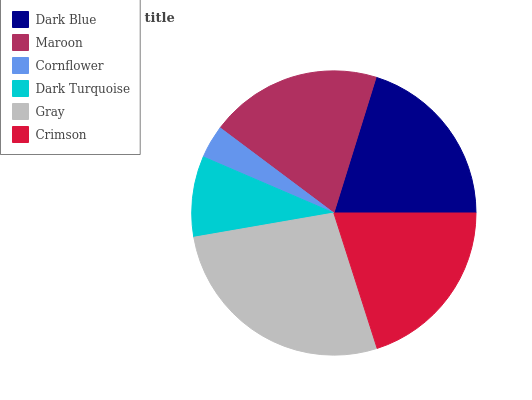Is Cornflower the minimum?
Answer yes or no. Yes. Is Gray the maximum?
Answer yes or no. Yes. Is Maroon the minimum?
Answer yes or no. No. Is Maroon the maximum?
Answer yes or no. No. Is Dark Blue greater than Maroon?
Answer yes or no. Yes. Is Maroon less than Dark Blue?
Answer yes or no. Yes. Is Maroon greater than Dark Blue?
Answer yes or no. No. Is Dark Blue less than Maroon?
Answer yes or no. No. Is Crimson the high median?
Answer yes or no. Yes. Is Maroon the low median?
Answer yes or no. Yes. Is Dark Blue the high median?
Answer yes or no. No. Is Dark Turquoise the low median?
Answer yes or no. No. 